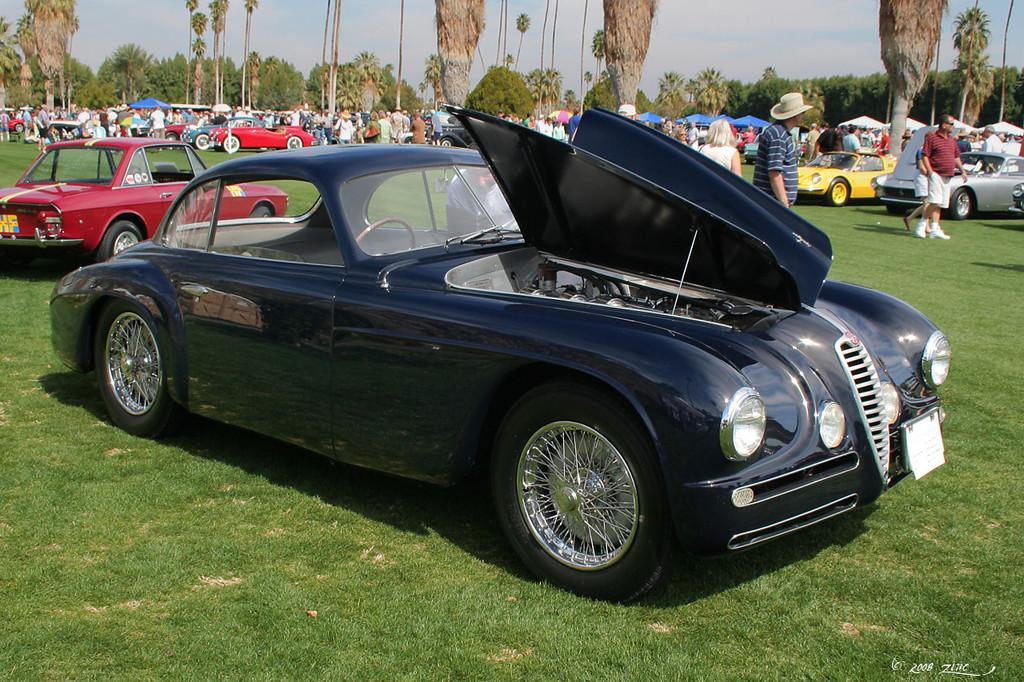In one or two sentences, can you explain what this image depicts? In this image I can see few vehicles which are in different color. These vehicles are on the ground. To the side of the vehicles I can see the group of people are standing with different color dresses and few people with the hats. In the background there are many trees and the sky. 